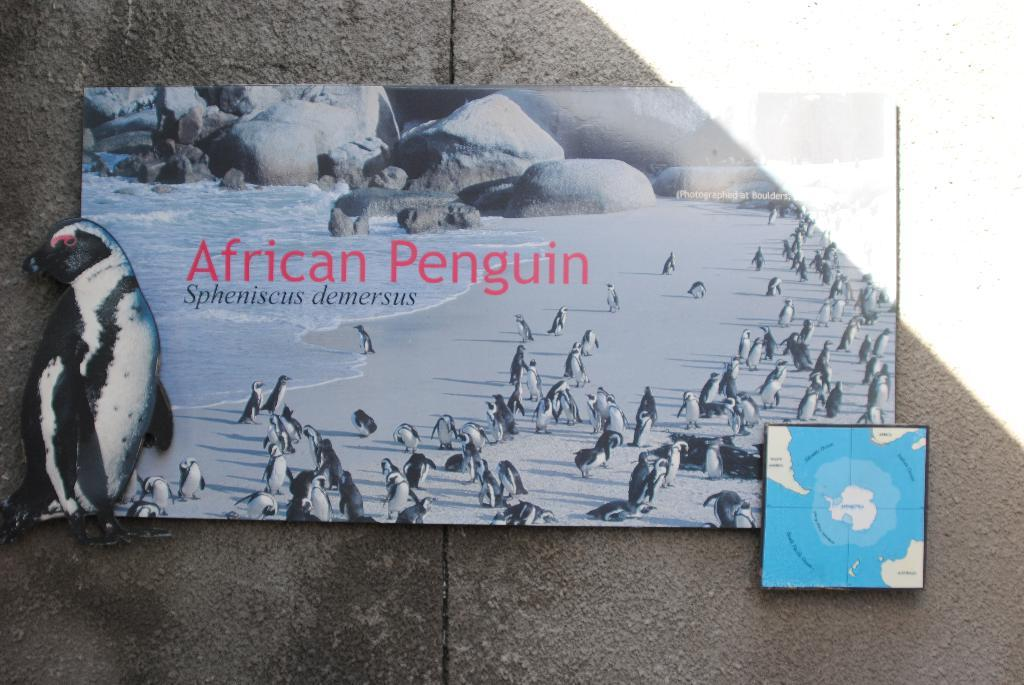What type of animals are in the image? There are penguins in the image. What is the primary element in which the penguins are situated? There is water visible in the image, and the penguins are likely in or near the water. What other objects or features can be seen in the image? There are rocks in the image. What is the blue and white object in the image? There is a blue and white color board in the image. Where is the color board located? The board is attached to a wall. How does the digestion process of the penguins differ from that of wool-producing animals in the image? There are no wool-producing animals present in the image, and the penguins' digestion process is not mentioned or visible. 